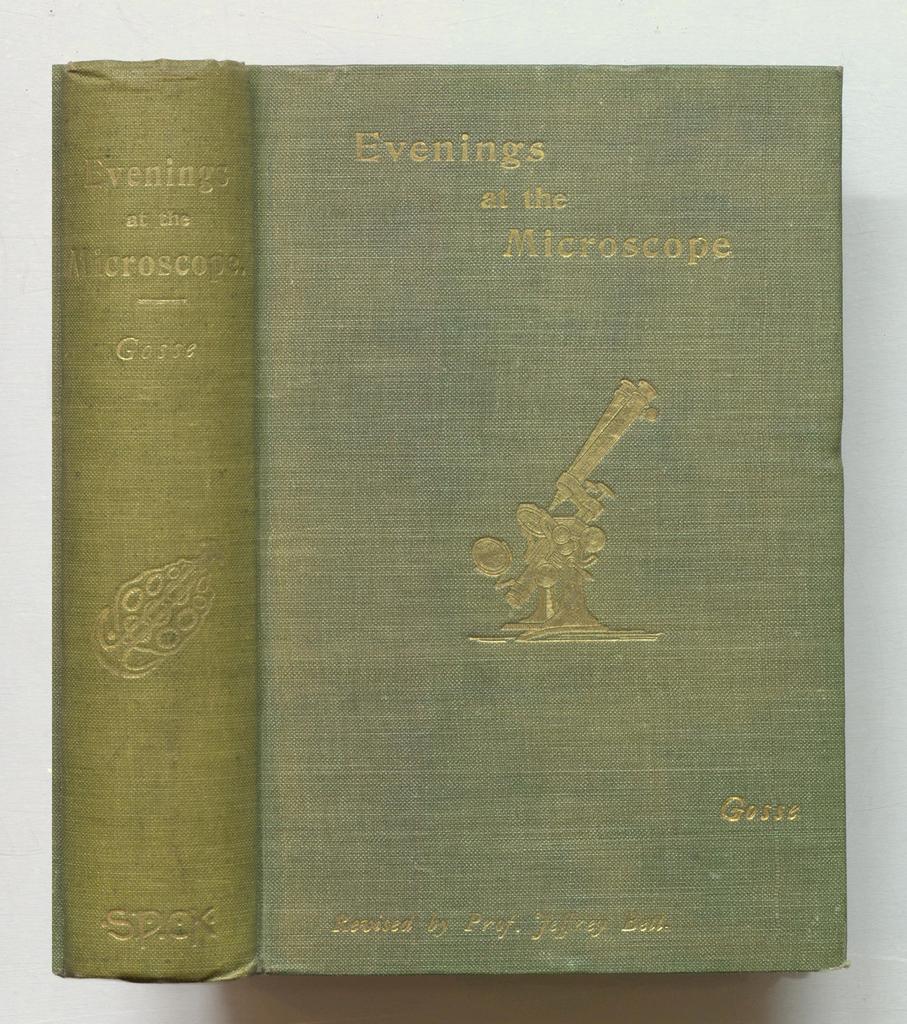What science tool is this book about?
Your answer should be very brief. Microscope. Who is the author?
Provide a short and direct response. Gosse. 